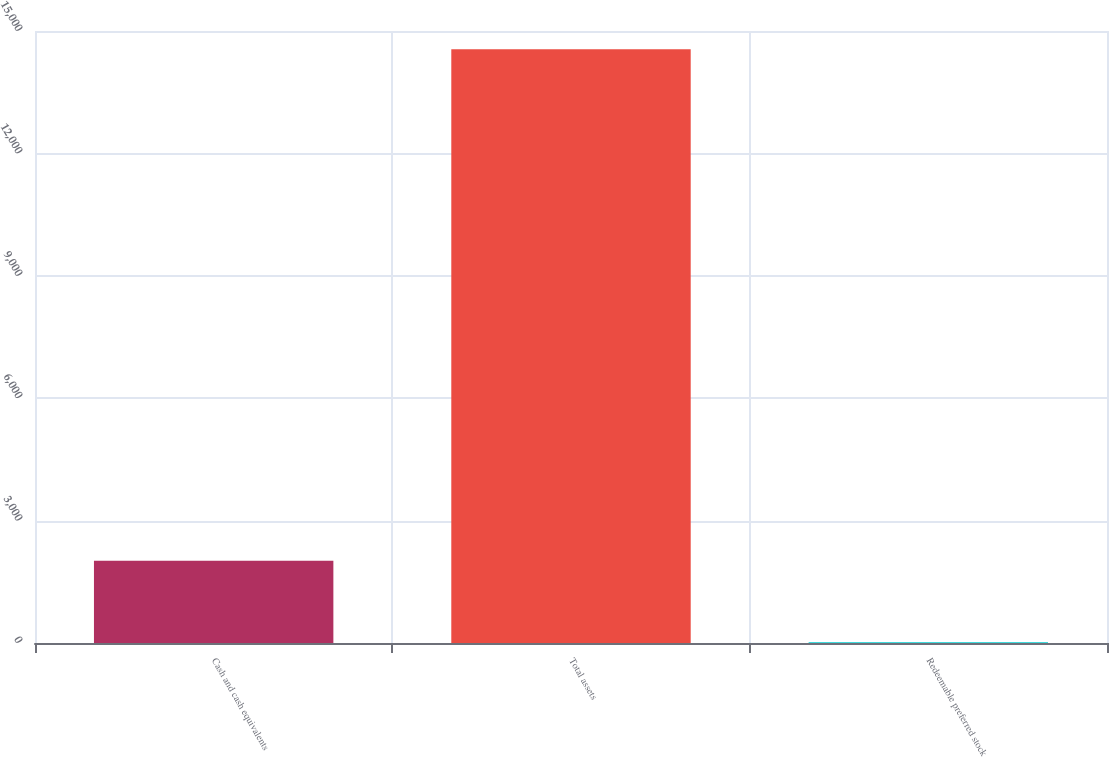Convert chart. <chart><loc_0><loc_0><loc_500><loc_500><bar_chart><fcel>Cash and cash equivalents<fcel>Total assets<fcel>Redeemable preferred stock<nl><fcel>2016<fcel>14552<fcel>20<nl></chart> 